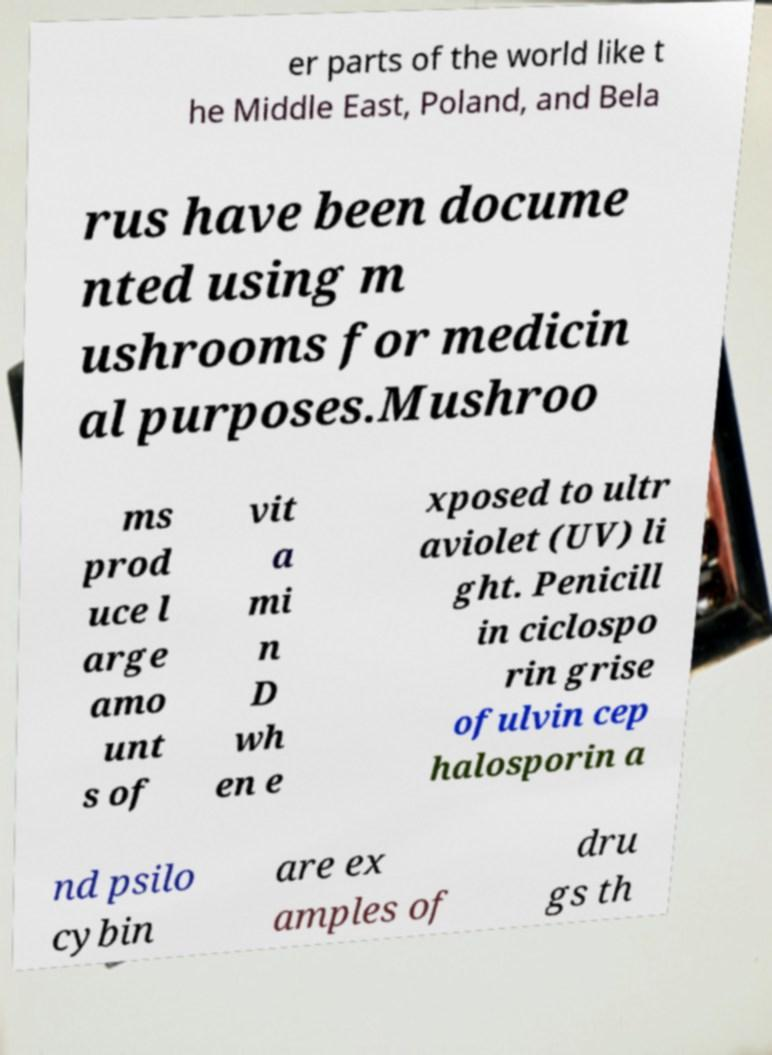Please read and relay the text visible in this image. What does it say? er parts of the world like t he Middle East, Poland, and Bela rus have been docume nted using m ushrooms for medicin al purposes.Mushroo ms prod uce l arge amo unt s of vit a mi n D wh en e xposed to ultr aviolet (UV) li ght. Penicill in ciclospo rin grise ofulvin cep halosporin a nd psilo cybin are ex amples of dru gs th 